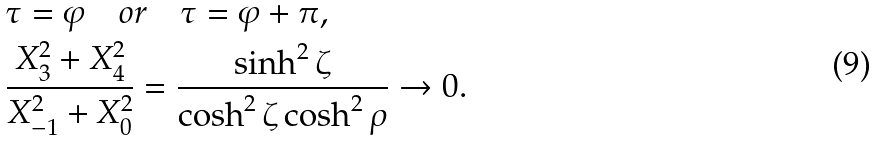<formula> <loc_0><loc_0><loc_500><loc_500>& \tau = \varphi \quad o r \quad \tau = \varphi + \pi , \\ & \frac { X _ { 3 } ^ { 2 } + X _ { 4 } ^ { 2 } } { X _ { - 1 } ^ { 2 } + X _ { 0 } ^ { 2 } } = \frac { \sinh ^ { 2 } \zeta } { \cosh ^ { 2 } \zeta \cosh ^ { 2 } \rho } \rightarrow 0 .</formula> 